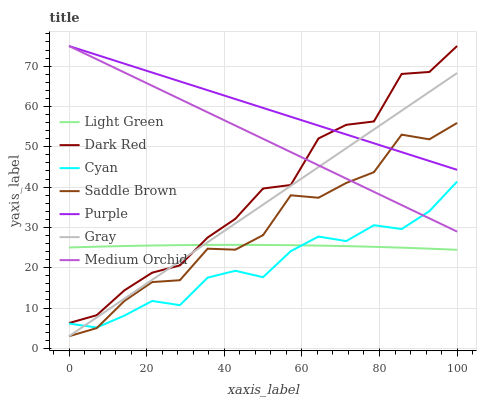Does Cyan have the minimum area under the curve?
Answer yes or no. Yes. Does Purple have the maximum area under the curve?
Answer yes or no. Yes. Does Dark Red have the minimum area under the curve?
Answer yes or no. No. Does Dark Red have the maximum area under the curve?
Answer yes or no. No. Is Gray the smoothest?
Answer yes or no. Yes. Is Dark Red the roughest?
Answer yes or no. Yes. Is Purple the smoothest?
Answer yes or no. No. Is Purple the roughest?
Answer yes or no. No. Does Gray have the lowest value?
Answer yes or no. Yes. Does Dark Red have the lowest value?
Answer yes or no. No. Does Medium Orchid have the highest value?
Answer yes or no. Yes. Does Light Green have the highest value?
Answer yes or no. No. Is Light Green less than Medium Orchid?
Answer yes or no. Yes. Is Dark Red greater than Cyan?
Answer yes or no. Yes. Does Medium Orchid intersect Purple?
Answer yes or no. Yes. Is Medium Orchid less than Purple?
Answer yes or no. No. Is Medium Orchid greater than Purple?
Answer yes or no. No. Does Light Green intersect Medium Orchid?
Answer yes or no. No. 